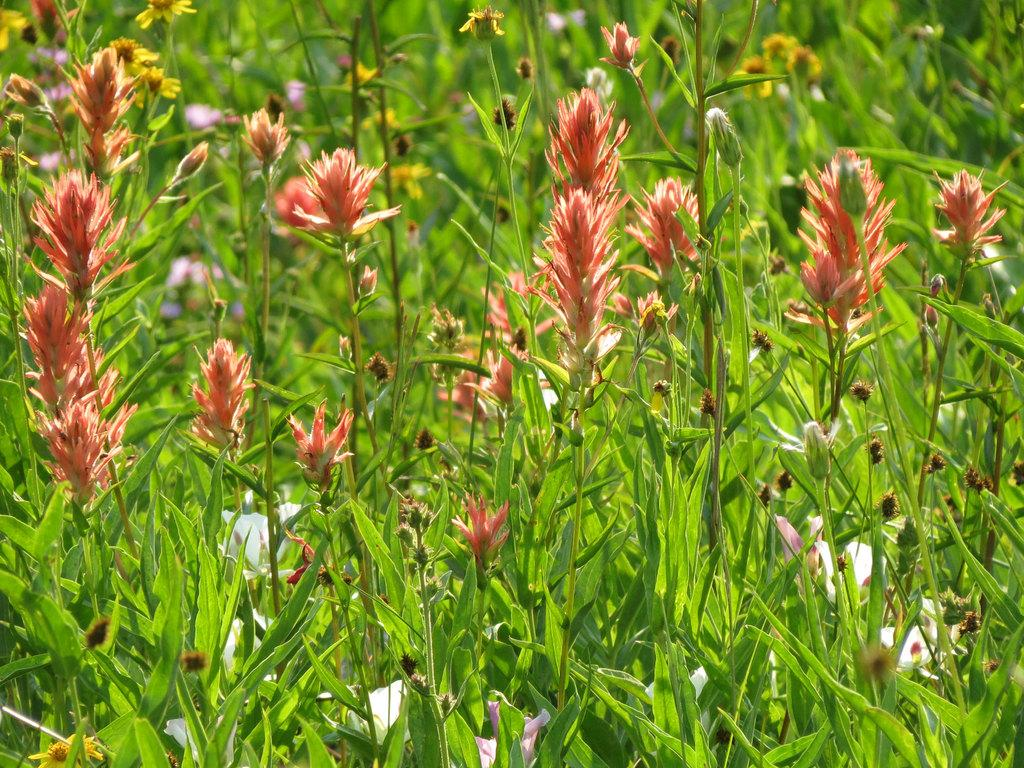What types of living organisms are in the image? The image contains plants and flowers. Can you describe the background of the image? The background of the image is blurred. What can be seen in the background of the image? There is greenery in the background of the image. What type of van can be seen in the image? There is no van present in the image; it features plants and flowers with a blurred background. What advice would the mother in the image give about the brake system of a car? There is no mother or reference to a car's brake system in the image. 